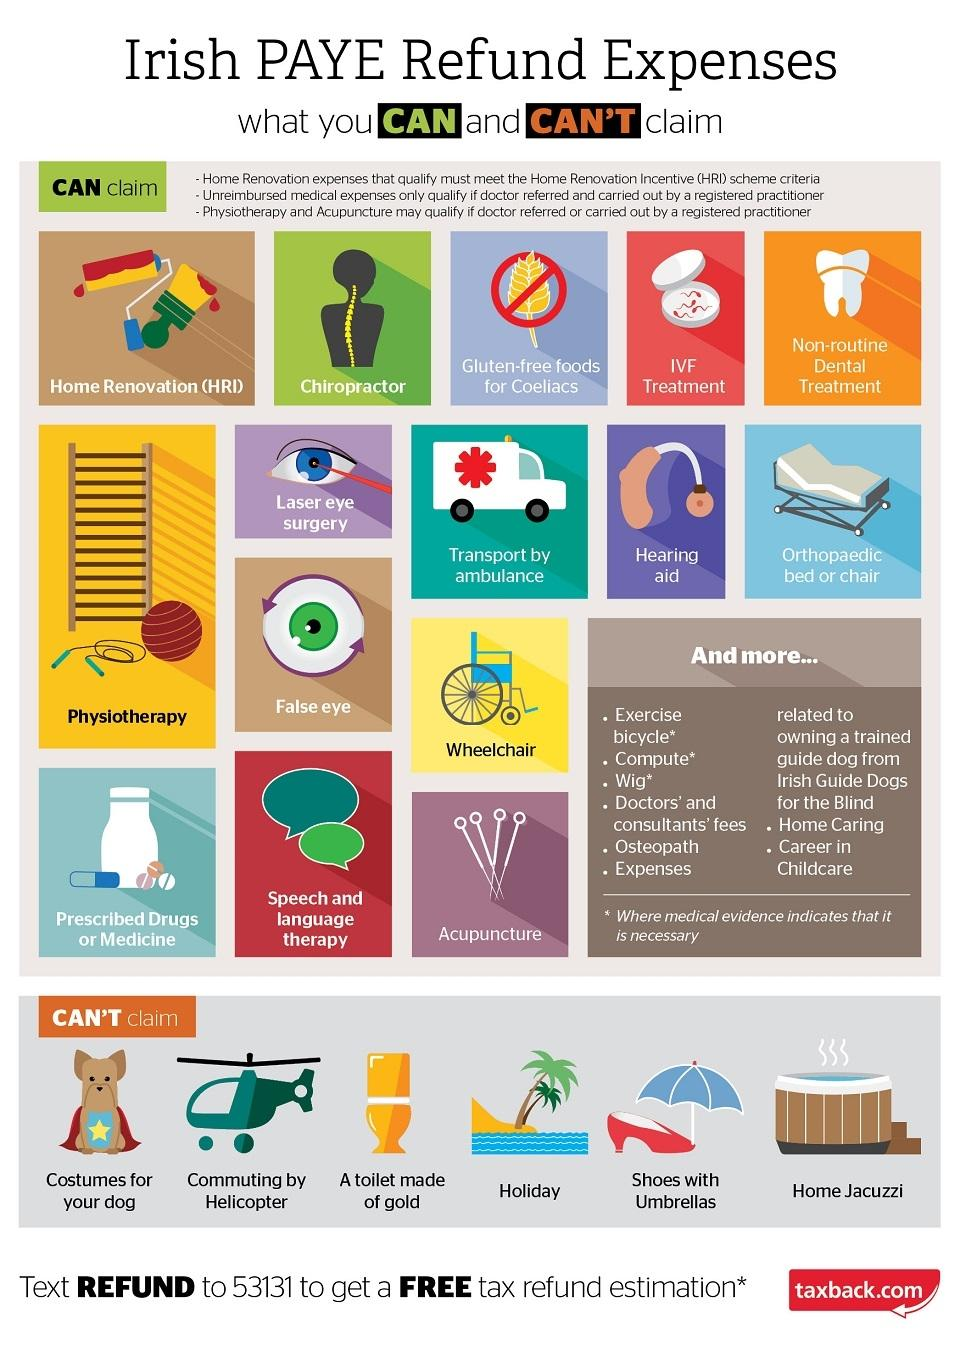Indicate a few pertinent items in this graphic. The possibility of claiming a PAYE refund for a home jacuzzi is not possible, as it cannot be claimed. Is it possible to claim a PAYE refund for an exercise bicycle? The answer is yes, you can claim a PAYE refund for an exercise bicycle. 